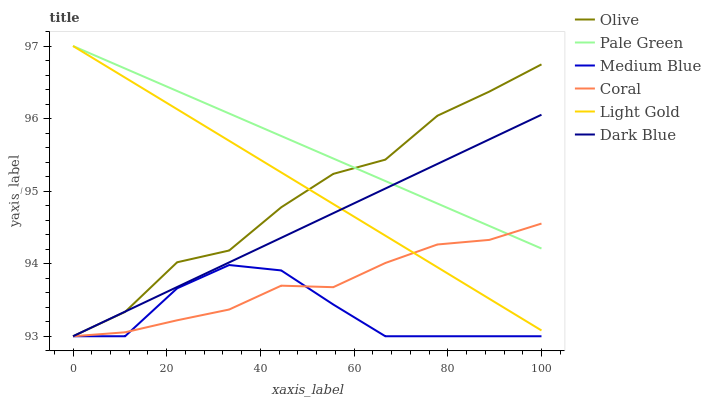Does Dark Blue have the minimum area under the curve?
Answer yes or no. No. Does Dark Blue have the maximum area under the curve?
Answer yes or no. No. Is Medium Blue the smoothest?
Answer yes or no. No. Is Medium Blue the roughest?
Answer yes or no. No. Does Pale Green have the lowest value?
Answer yes or no. No. Does Dark Blue have the highest value?
Answer yes or no. No. Is Medium Blue less than Light Gold?
Answer yes or no. Yes. Is Light Gold greater than Medium Blue?
Answer yes or no. Yes. Does Medium Blue intersect Light Gold?
Answer yes or no. No. 